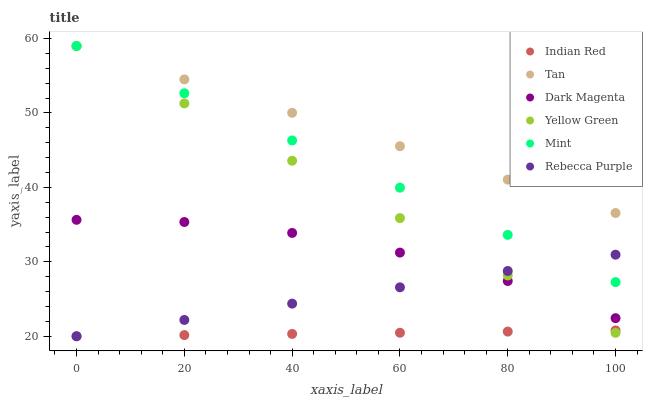Does Indian Red have the minimum area under the curve?
Answer yes or no. Yes. Does Tan have the maximum area under the curve?
Answer yes or no. Yes. Does Rebecca Purple have the minimum area under the curve?
Answer yes or no. No. Does Rebecca Purple have the maximum area under the curve?
Answer yes or no. No. Is Rebecca Purple the smoothest?
Answer yes or no. Yes. Is Dark Magenta the roughest?
Answer yes or no. Yes. Is Indian Red the smoothest?
Answer yes or no. No. Is Indian Red the roughest?
Answer yes or no. No. Does Rebecca Purple have the lowest value?
Answer yes or no. Yes. Does Tan have the lowest value?
Answer yes or no. No. Does Yellow Green have the highest value?
Answer yes or no. Yes. Does Rebecca Purple have the highest value?
Answer yes or no. No. Is Indian Red less than Dark Magenta?
Answer yes or no. Yes. Is Mint greater than Indian Red?
Answer yes or no. Yes. Does Mint intersect Tan?
Answer yes or no. Yes. Is Mint less than Tan?
Answer yes or no. No. Is Mint greater than Tan?
Answer yes or no. No. Does Indian Red intersect Dark Magenta?
Answer yes or no. No. 